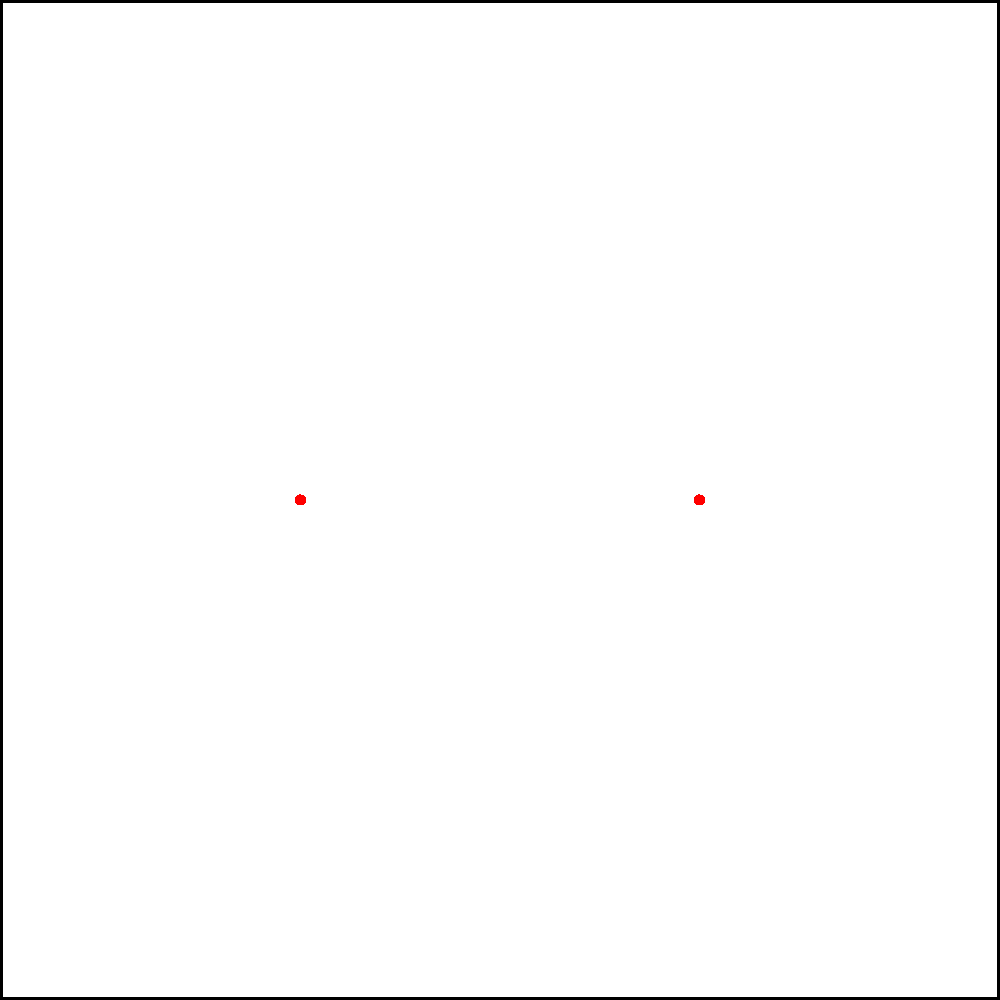In a ripple tank experiment, two coherent point sources S1 and S2 are placed 4 cm apart, producing waves with a wavelength of 1 cm. Calculate the angle θ (in degrees) between the central maximum and the first-order maximum in the interference pattern. To solve this problem, we'll follow these steps:

1) First, recall the equation for the path difference (Δr) that produces constructive interference:

   $$\Delta r = n\lambda$$

   where n is the order of the maximum (0, 1, 2, ...) and λ is the wavelength.

2) For the first-order maximum, n = 1, so:

   $$\Delta r = \lambda = 1 \text{ cm}$$

3) Now, consider the geometry of the situation. If we draw a line from the midpoint between the sources to a point on the first-order maximum, it forms a right triangle with half the distance between the sources.

4) In this triangle:
   - The hypotenuse is the distance to the screen (let's call it L)
   - Half the distance between the sources is 2 cm
   - The angle we're looking for is θ

5) The path difference Δr is related to the angle θ by:

   $$\Delta r = d \sin \theta$$

   where d is the distance between the sources (4 cm).

6) Substituting what we know:

   $$1 \text{ cm} = 4 \text{ cm} \cdot \sin \theta$$

7) Solving for θ:

   $$\sin \theta = \frac{1}{4}$$
   $$\theta = \arcsin(\frac{1}{4})$$

8) Converting to degrees:

   $$\theta = \arcsin(\frac{1}{4}) \cdot \frac{180°}{\pi}$$
Answer: $14.48°$ 